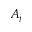Convert formula to latex. <formula><loc_0><loc_0><loc_500><loc_500>A _ { j }</formula> 